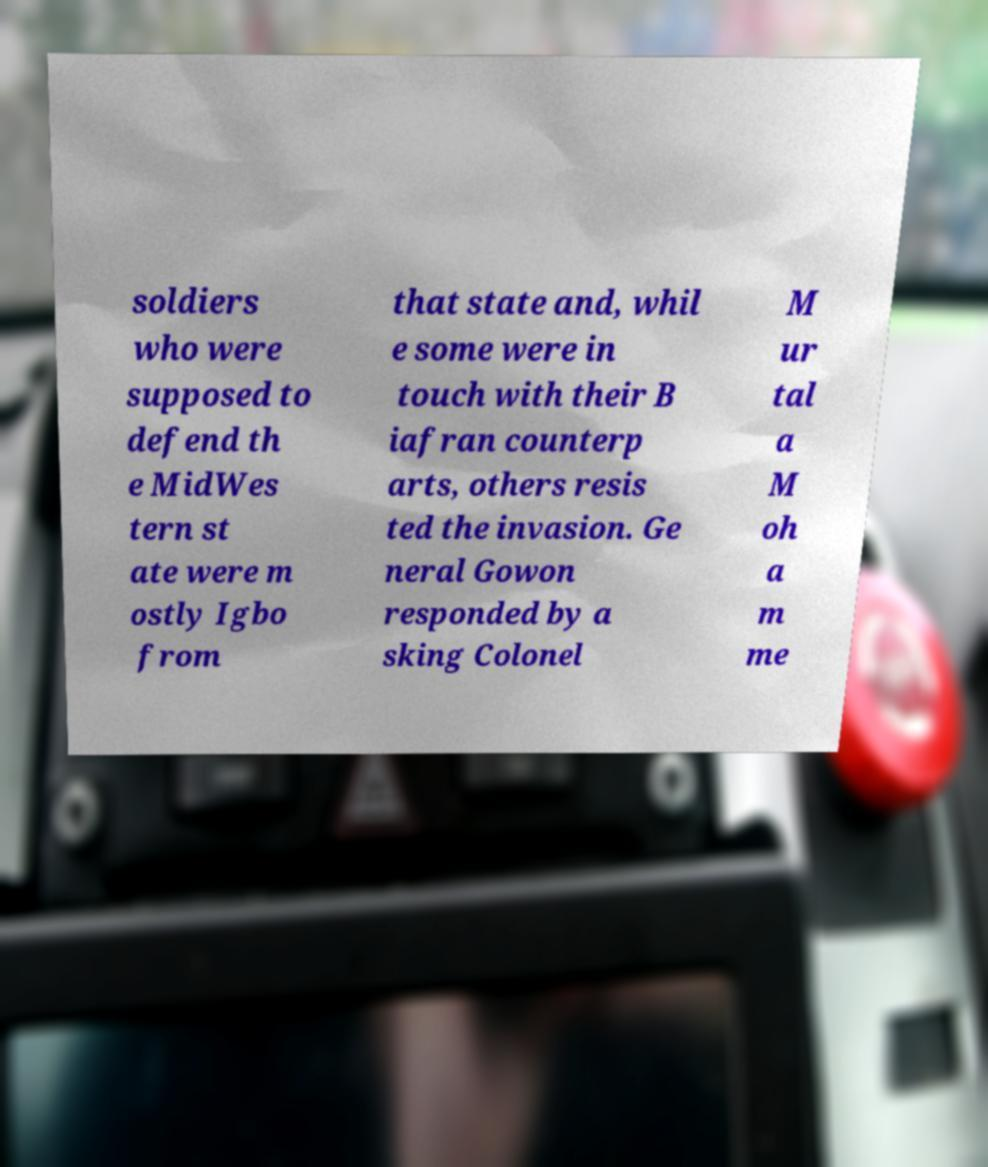For documentation purposes, I need the text within this image transcribed. Could you provide that? soldiers who were supposed to defend th e MidWes tern st ate were m ostly Igbo from that state and, whil e some were in touch with their B iafran counterp arts, others resis ted the invasion. Ge neral Gowon responded by a sking Colonel M ur tal a M oh a m me 